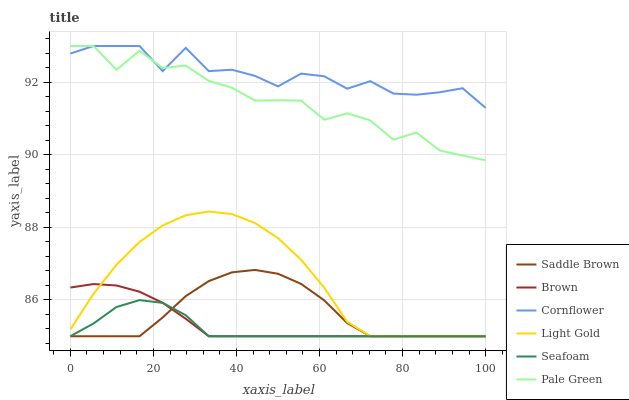Does Seafoam have the minimum area under the curve?
Answer yes or no. Yes. Does Cornflower have the maximum area under the curve?
Answer yes or no. Yes. Does Cornflower have the minimum area under the curve?
Answer yes or no. No. Does Seafoam have the maximum area under the curve?
Answer yes or no. No. Is Brown the smoothest?
Answer yes or no. Yes. Is Pale Green the roughest?
Answer yes or no. Yes. Is Cornflower the smoothest?
Answer yes or no. No. Is Cornflower the roughest?
Answer yes or no. No. Does Brown have the lowest value?
Answer yes or no. Yes. Does Cornflower have the lowest value?
Answer yes or no. No. Does Pale Green have the highest value?
Answer yes or no. Yes. Does Seafoam have the highest value?
Answer yes or no. No. Is Brown less than Cornflower?
Answer yes or no. Yes. Is Pale Green greater than Brown?
Answer yes or no. Yes. Does Seafoam intersect Saddle Brown?
Answer yes or no. Yes. Is Seafoam less than Saddle Brown?
Answer yes or no. No. Is Seafoam greater than Saddle Brown?
Answer yes or no. No. Does Brown intersect Cornflower?
Answer yes or no. No. 